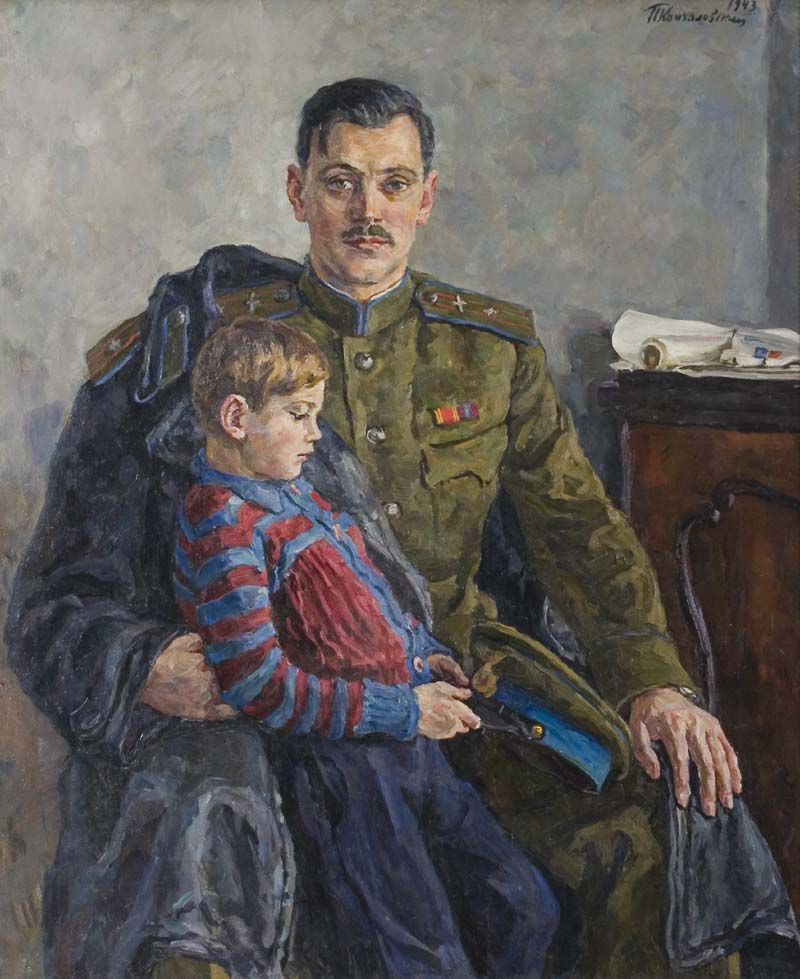Describe a short realistic scenario where the father in the painting has to leave for deployment. In a brief, heartfelt exchange, the uniformed man kneels beside his son, who clutches a small toy soldier resembling his father. Bringing his son into a tight embrace, he whispers words of reassurance, explaining that duty calls him away for a time. Gathering his gear, he exchanges a lingering look with his family, embodying both the gravity of his commitment and the deep love binding them together. The boy watches with wide eyes, understanding that while his father will be gone, his love remains steadfast. 